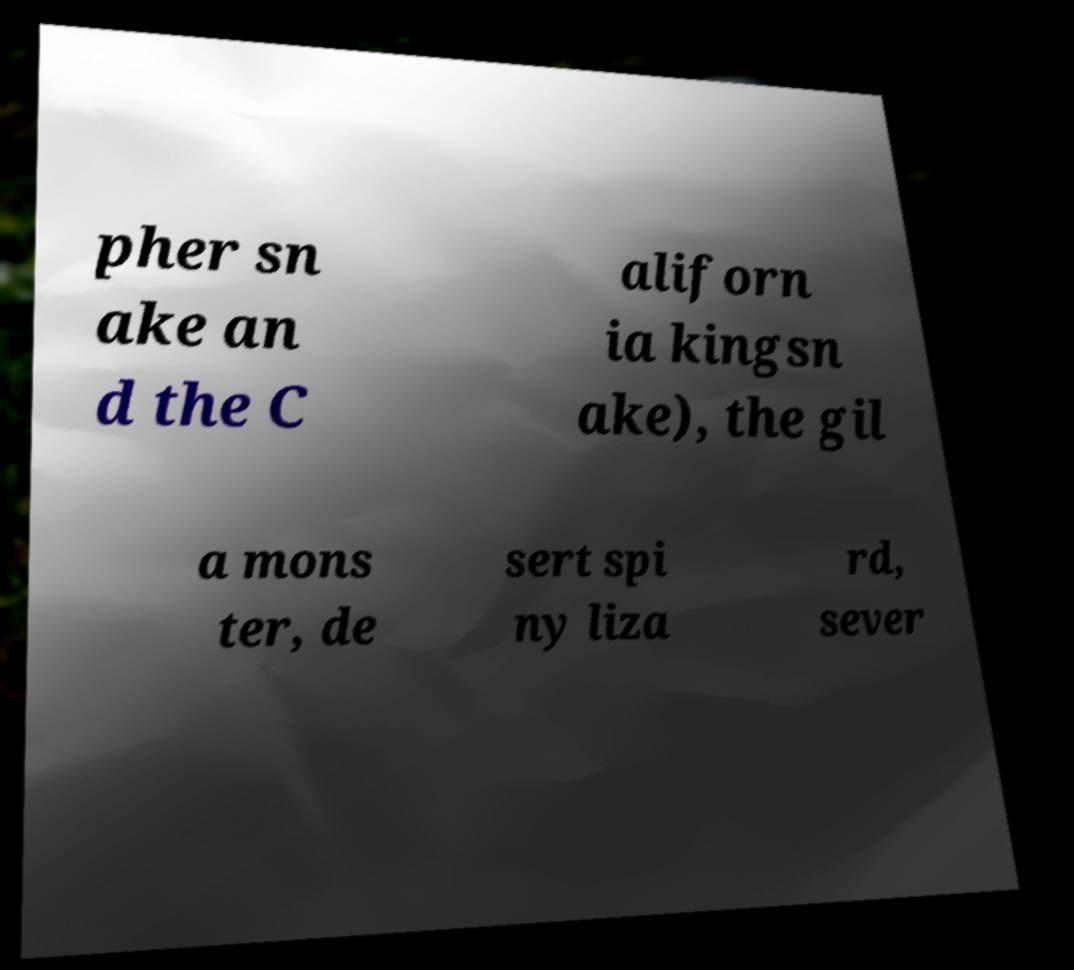Can you read and provide the text displayed in the image?This photo seems to have some interesting text. Can you extract and type it out for me? pher sn ake an d the C aliforn ia kingsn ake), the gil a mons ter, de sert spi ny liza rd, sever 